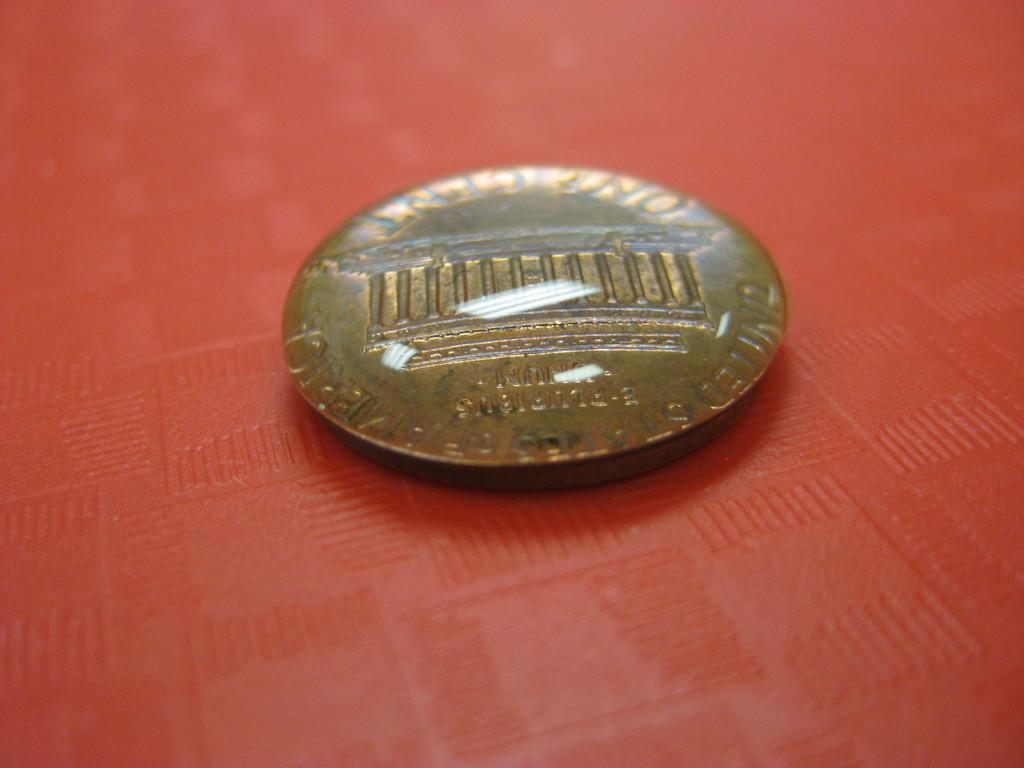<image>
Summarize the visual content of the image. A rounded penny coin says Pluribus on it. 